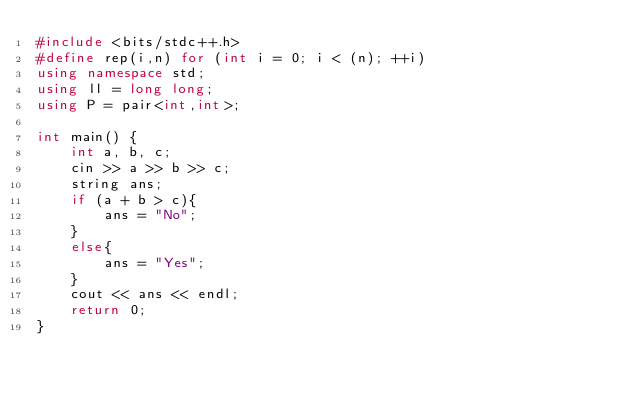<code> <loc_0><loc_0><loc_500><loc_500><_C++_>#include <bits/stdc++.h>
#define rep(i,n) for (int i = 0; i < (n); ++i)
using namespace std;
using ll = long long;
using P = pair<int,int>;

int main() {
	int a, b, c;
	cin >> a >> b >> c;
	string ans;
	if (a + b > c){
		ans = "No";
	}
	else{
		ans = "Yes";
	}
	cout << ans << endl;
	return 0;
}
</code> 